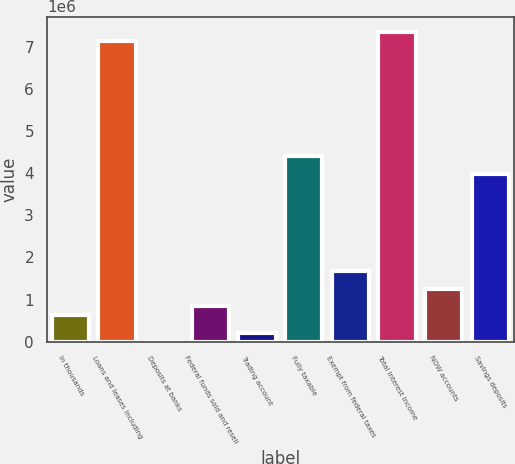Convert chart. <chart><loc_0><loc_0><loc_500><loc_500><bar_chart><fcel>In thousands<fcel>Loans and leases including<fcel>Deposits at banks<fcel>Federal funds sold and resell<fcel>Trading account<fcel>Fully taxable<fcel>Exempt from federal taxes<fcel>Total interest income<fcel>NOW accounts<fcel>Savings deposits<nl><fcel>630647<fcel>7.14613e+06<fcel>116<fcel>840824<fcel>210293<fcel>4.41383e+06<fcel>1.68153e+06<fcel>7.35631e+06<fcel>1.26118e+06<fcel>3.99348e+06<nl></chart> 